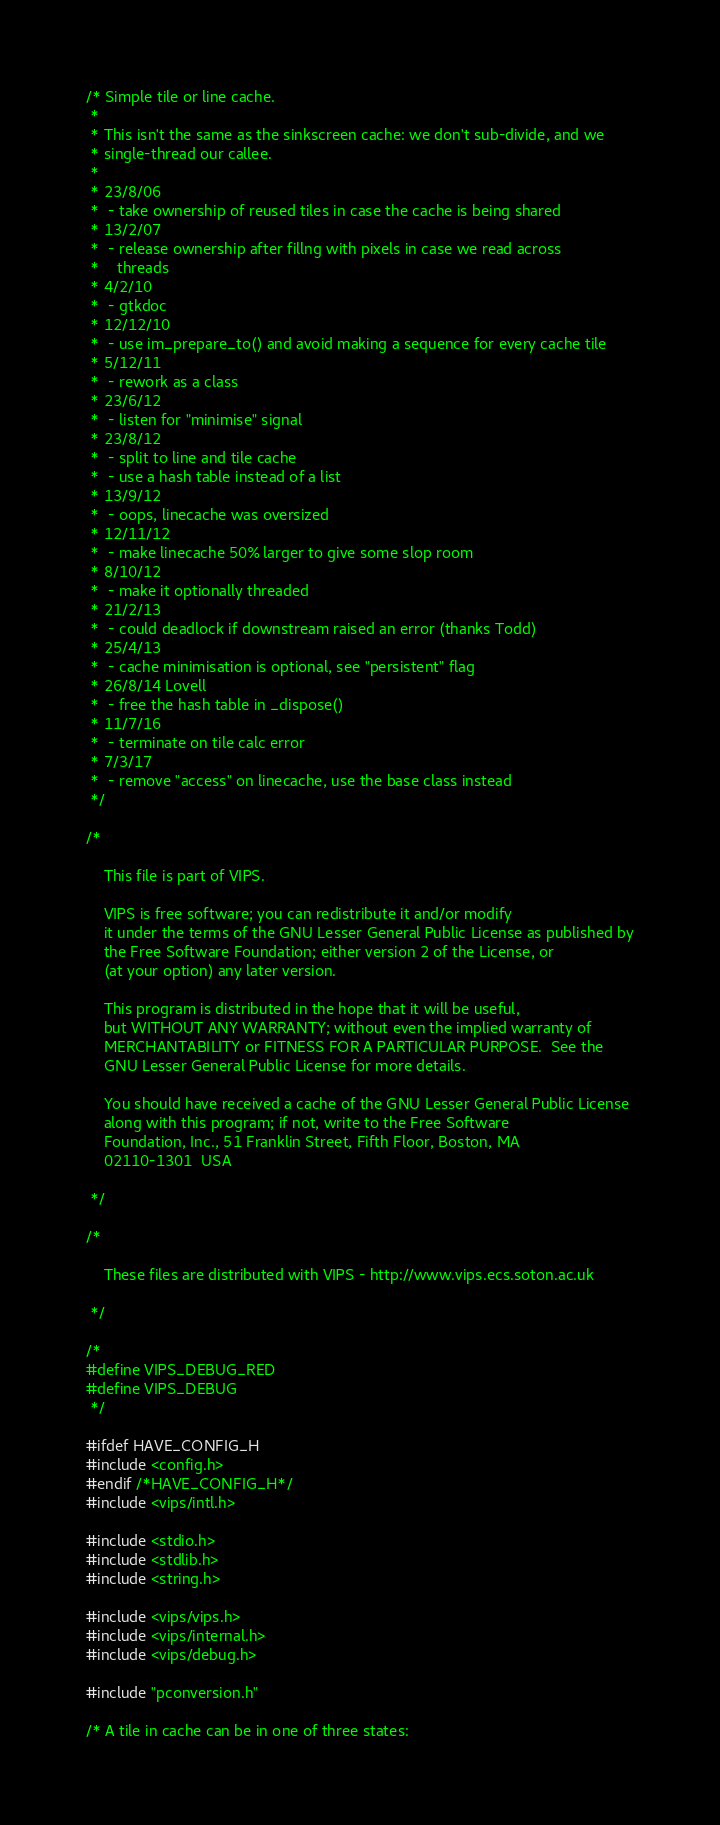Convert code to text. <code><loc_0><loc_0><loc_500><loc_500><_C_>/* Simple tile or line cache.
 *
 * This isn't the same as the sinkscreen cache: we don't sub-divide, and we 
 * single-thread our callee.
 *
 * 23/8/06
 * 	- take ownership of reused tiles in case the cache is being shared
 * 13/2/07
 * 	- release ownership after fillng with pixels in case we read across
 * 	  threads
 * 4/2/10
 * 	- gtkdoc
 * 12/12/10
 * 	- use im_prepare_to() and avoid making a sequence for every cache tile
 * 5/12/11
 * 	- rework as a class
 * 23/6/12
 * 	- listen for "minimise" signal
 * 23/8/12
 * 	- split to line and tile cache
 * 	- use a hash table instead of a list
 * 13/9/12
 * 	- oops, linecache was oversized
 * 12/11/12
 * 	- make linecache 50% larger to give some slop room
 * 8/10/12
 * 	- make it optionally threaded
 * 21/2/13
 * 	- could deadlock if downstream raised an error (thanks Todd)
 * 25/4/13
 * 	- cache minimisation is optional, see "persistent" flag
 * 26/8/14 Lovell
 * 	- free the hash table in _dispose()
 * 11/7/16
 * 	- terminate on tile calc error
 * 7/3/17
 * 	- remove "access" on linecache, use the base class instead
 */

/*

    This file is part of VIPS.
    
    VIPS is free software; you can redistribute it and/or modify
    it under the terms of the GNU Lesser General Public License as published by
    the Free Software Foundation; either version 2 of the License, or
    (at your option) any later version.

    This program is distributed in the hope that it will be useful,
    but WITHOUT ANY WARRANTY; without even the implied warranty of
    MERCHANTABILITY or FITNESS FOR A PARTICULAR PURPOSE.  See the
    GNU Lesser General Public License for more details.

    You should have received a cache of the GNU Lesser General Public License
    along with this program; if not, write to the Free Software
    Foundation, Inc., 51 Franklin Street, Fifth Floor, Boston, MA
    02110-1301  USA

 */

/*

    These files are distributed with VIPS - http://www.vips.ecs.soton.ac.uk

 */

/*
#define VIPS_DEBUG_RED
#define VIPS_DEBUG
 */

#ifdef HAVE_CONFIG_H
#include <config.h>
#endif /*HAVE_CONFIG_H*/
#include <vips/intl.h>

#include <stdio.h>
#include <stdlib.h>
#include <string.h>

#include <vips/vips.h>
#include <vips/internal.h>
#include <vips/debug.h>

#include "pconversion.h"

/* A tile in cache can be in one of three states:</code> 